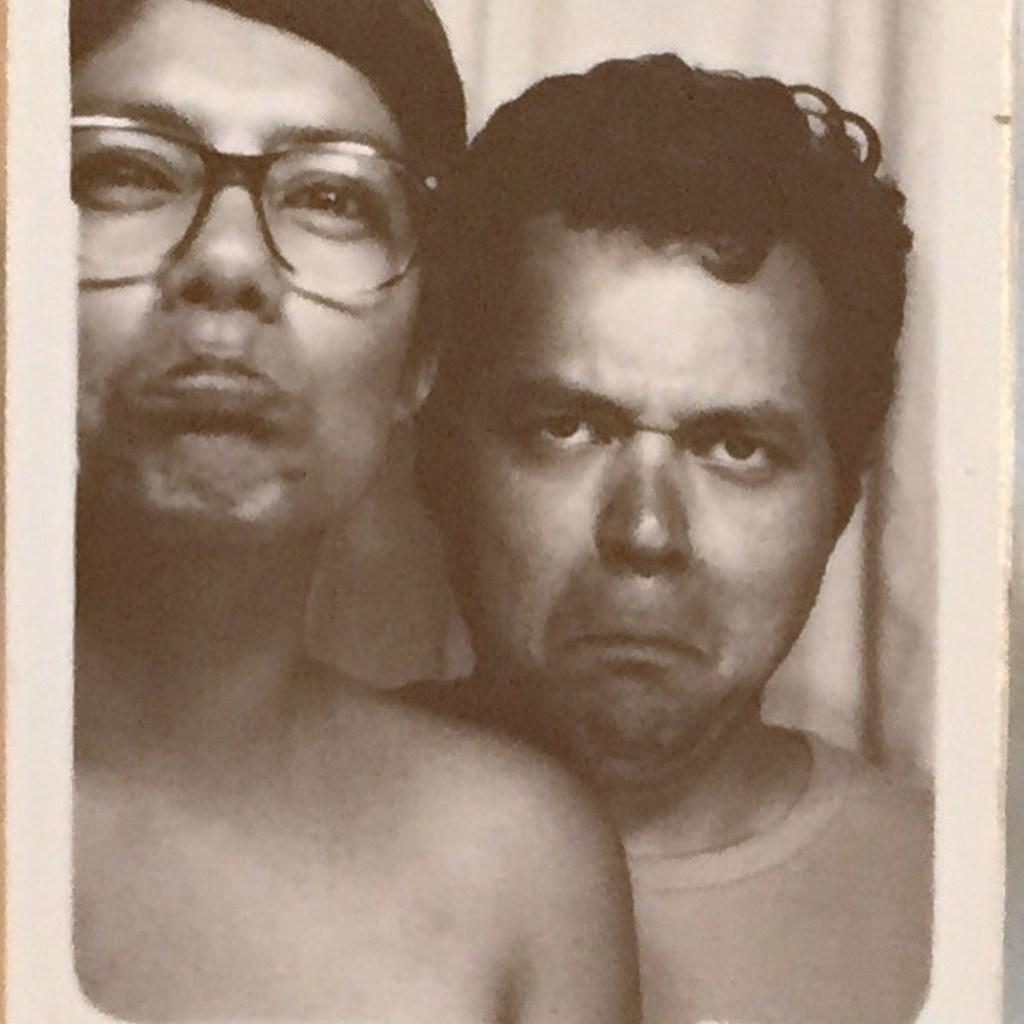How many people are in the image? There are two men in the image. What are the men doing in the image? The men are standing in front of a wall. What is the color scheme of the image? The image is black and white. What type of support can be seen in the image? There is no support visible in the image; it only features two men standing in front of a wall. What kind of steel is used in the construction of the wall in the image? The image is black and white, and there is no information about the construction materials of the wall. 